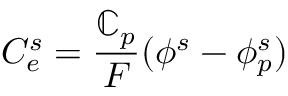<formula> <loc_0><loc_0><loc_500><loc_500>C _ { e } ^ { s } = \frac { \mathbb { C } _ { p } } { F } ( \phi ^ { s } - \phi _ { p } ^ { s } )</formula> 